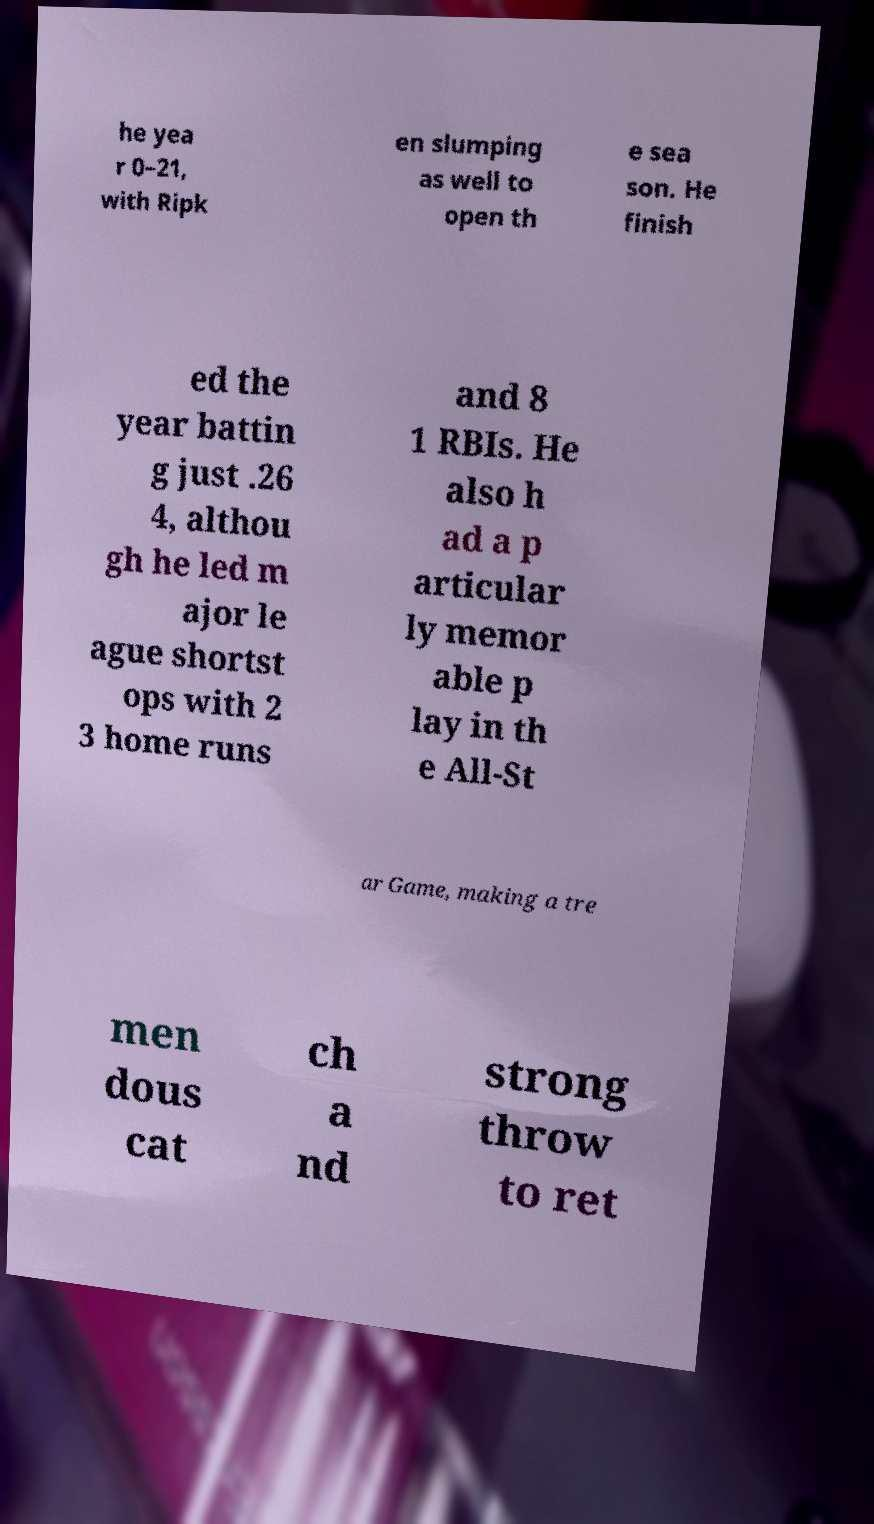Can you accurately transcribe the text from the provided image for me? he yea r 0–21, with Ripk en slumping as well to open th e sea son. He finish ed the year battin g just .26 4, althou gh he led m ajor le ague shortst ops with 2 3 home runs and 8 1 RBIs. He also h ad a p articular ly memor able p lay in th e All-St ar Game, making a tre men dous cat ch a nd strong throw to ret 